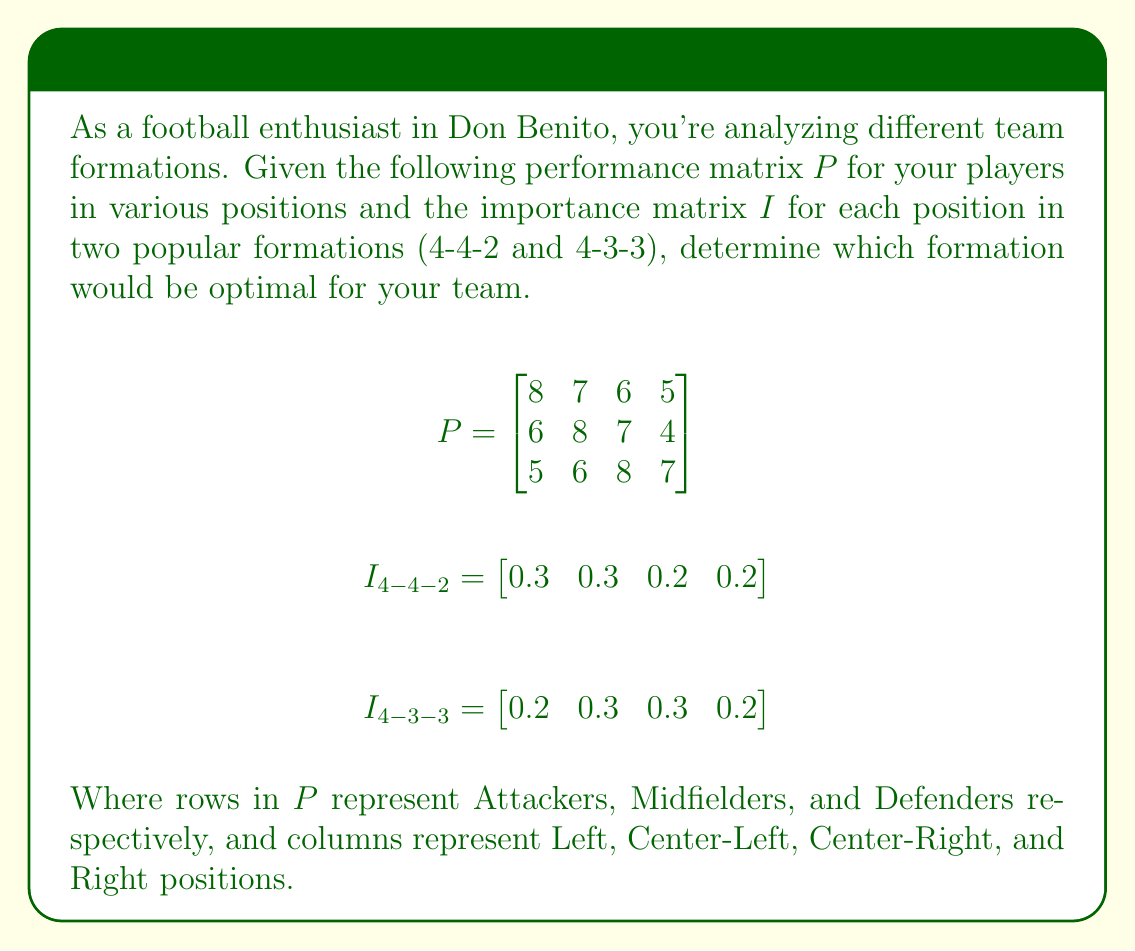Teach me how to tackle this problem. To solve this problem, we need to multiply the performance matrix $P$ with each importance matrix $I$ and compare the results. The higher total score indicates the optimal formation.

Step 1: Calculate the score for the 4-4-2 formation
$$S_{4-4-2} = I_{4-4-2} \cdot P^T$$

$S_{4-4-2} = \begin{bmatrix} 0.3 & 0.3 & 0.2 & 0.2 \end{bmatrix} \cdot \begin{bmatrix}
8 & 6 & 5 \\
7 & 8 & 6 \\
6 & 7 & 8 \\
5 & 4 & 7
\end{bmatrix}$

$S_{4-4-2} = \begin{bmatrix} (0.3 \cdot 8 + 0.3 \cdot 7 + 0.2 \cdot 6 + 0.2 \cdot 5) & (0.3 \cdot 6 + 0.3 \cdot 8 + 0.2 \cdot 7 + 0.2 \cdot 4) & (0.3 \cdot 5 + 0.3 \cdot 6 + 0.2 \cdot 8 + 0.2 \cdot 7) \end{bmatrix}$

$S_{4-4-2} = \begin{bmatrix} 6.7 & 6.5 & 6.3 \end{bmatrix}$

Total score for 4-4-2: $6.7 + 6.5 + 6.3 = 19.5$

Step 2: Calculate the score for the 4-3-3 formation
$$S_{4-3-3} = I_{4-3-3} \cdot P^T$$

$S_{4-3-3} = \begin{bmatrix} 0.2 & 0.3 & 0.3 & 0.2 \end{bmatrix} \cdot \begin{bmatrix}
8 & 6 & 5 \\
7 & 8 & 6 \\
6 & 7 & 8 \\
5 & 4 & 7
\end{bmatrix}$

$S_{4-3-3} = \begin{bmatrix} (0.2 \cdot 8 + 0.3 \cdot 7 + 0.3 \cdot 6 + 0.2 \cdot 5) & (0.2 \cdot 6 + 0.3 \cdot 8 + 0.3 \cdot 7 + 0.2 \cdot 4) & (0.2 \cdot 5 + 0.3 \cdot 6 + 0.3 \cdot 8 + 0.2 \cdot 7) \end{bmatrix}$

$S_{4-3-3} = \begin{bmatrix} 6.5 & 6.5 & 6.6 \end{bmatrix}$

Total score for 4-3-3: $6.5 + 6.5 + 6.6 = 19.6$

Step 3: Compare the total scores
4-4-2 formation: 19.5
4-3-3 formation: 19.6

Since 19.6 > 19.5, the 4-3-3 formation is optimal for the team.
Answer: 4-3-3 formation 